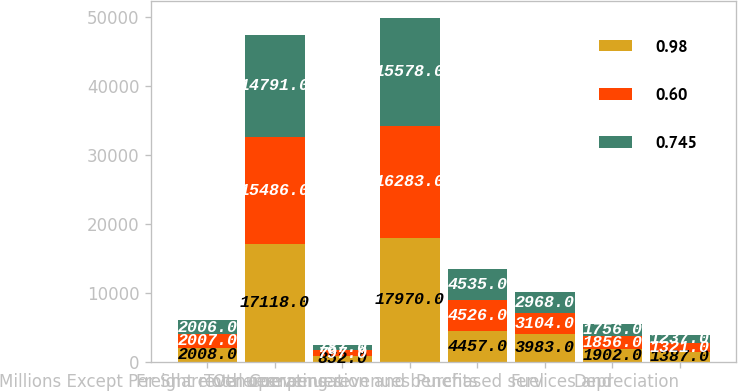Convert chart. <chart><loc_0><loc_0><loc_500><loc_500><stacked_bar_chart><ecel><fcel>Millions Except Per Share<fcel>Freight revenues<fcel>Other revenues<fcel>Total operating revenues<fcel>Compensation and benefits<fcel>Fuel<fcel>Purchased services and<fcel>Depreciation<nl><fcel>0.98<fcel>2008<fcel>17118<fcel>852<fcel>17970<fcel>4457<fcel>3983<fcel>1902<fcel>1387<nl><fcel>0.6<fcel>2007<fcel>15486<fcel>797<fcel>16283<fcel>4526<fcel>3104<fcel>1856<fcel>1321<nl><fcel>0.745<fcel>2006<fcel>14791<fcel>787<fcel>15578<fcel>4535<fcel>2968<fcel>1756<fcel>1237<nl></chart> 